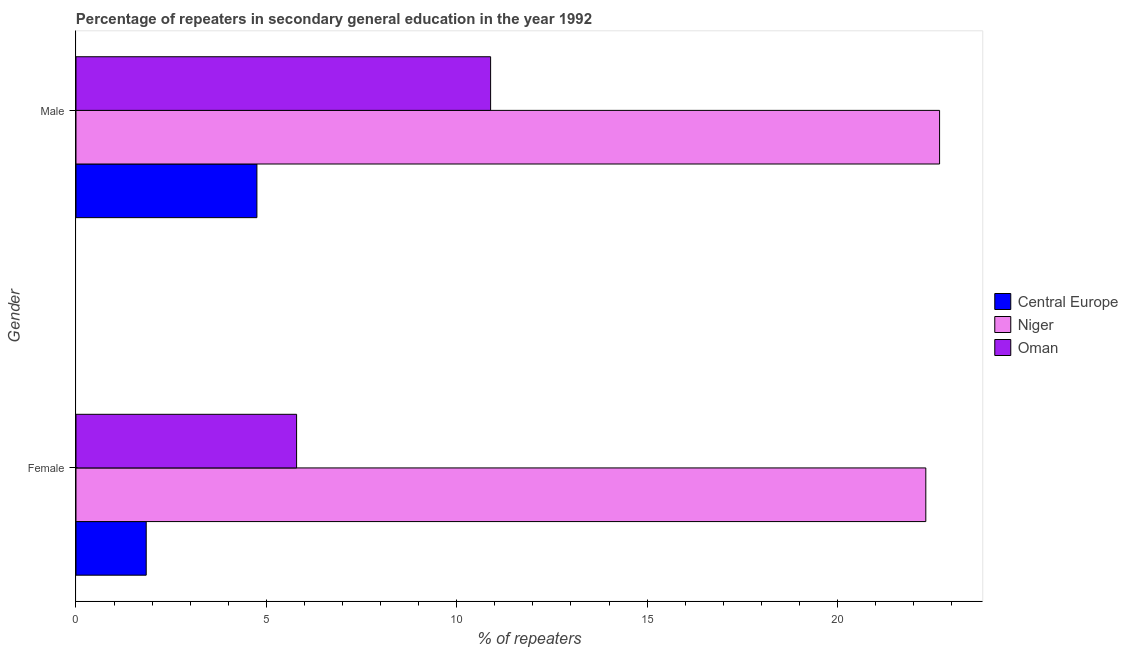How many different coloured bars are there?
Offer a very short reply. 3. How many groups of bars are there?
Your response must be concise. 2. Are the number of bars per tick equal to the number of legend labels?
Keep it short and to the point. Yes. What is the percentage of male repeaters in Central Europe?
Make the answer very short. 4.75. Across all countries, what is the maximum percentage of male repeaters?
Offer a terse response. 22.68. Across all countries, what is the minimum percentage of female repeaters?
Provide a succinct answer. 1.84. In which country was the percentage of female repeaters maximum?
Make the answer very short. Niger. In which country was the percentage of female repeaters minimum?
Provide a succinct answer. Central Europe. What is the total percentage of female repeaters in the graph?
Offer a terse response. 29.96. What is the difference between the percentage of male repeaters in Oman and that in Niger?
Your response must be concise. -11.79. What is the difference between the percentage of male repeaters in Central Europe and the percentage of female repeaters in Niger?
Your answer should be compact. -17.57. What is the average percentage of female repeaters per country?
Provide a succinct answer. 9.99. What is the difference between the percentage of female repeaters and percentage of male repeaters in Oman?
Provide a succinct answer. -5.1. What is the ratio of the percentage of male repeaters in Niger to that in Central Europe?
Provide a short and direct response. 4.77. What does the 2nd bar from the top in Female represents?
Keep it short and to the point. Niger. What does the 1st bar from the bottom in Male represents?
Provide a short and direct response. Central Europe. Are all the bars in the graph horizontal?
Keep it short and to the point. Yes. How many countries are there in the graph?
Offer a very short reply. 3. Are the values on the major ticks of X-axis written in scientific E-notation?
Make the answer very short. No. Does the graph contain any zero values?
Ensure brevity in your answer.  No. How many legend labels are there?
Provide a succinct answer. 3. What is the title of the graph?
Your answer should be compact. Percentage of repeaters in secondary general education in the year 1992. Does "Ireland" appear as one of the legend labels in the graph?
Offer a terse response. No. What is the label or title of the X-axis?
Keep it short and to the point. % of repeaters. What is the % of repeaters in Central Europe in Female?
Provide a short and direct response. 1.84. What is the % of repeaters in Niger in Female?
Offer a terse response. 22.32. What is the % of repeaters in Oman in Female?
Your answer should be very brief. 5.79. What is the % of repeaters in Central Europe in Male?
Give a very brief answer. 4.75. What is the % of repeaters in Niger in Male?
Provide a succinct answer. 22.68. What is the % of repeaters in Oman in Male?
Provide a succinct answer. 10.89. Across all Gender, what is the maximum % of repeaters in Central Europe?
Make the answer very short. 4.75. Across all Gender, what is the maximum % of repeaters in Niger?
Provide a succinct answer. 22.68. Across all Gender, what is the maximum % of repeaters in Oman?
Your answer should be very brief. 10.89. Across all Gender, what is the minimum % of repeaters in Central Europe?
Ensure brevity in your answer.  1.84. Across all Gender, what is the minimum % of repeaters of Niger?
Your response must be concise. 22.32. Across all Gender, what is the minimum % of repeaters of Oman?
Offer a terse response. 5.79. What is the total % of repeaters in Central Europe in the graph?
Your answer should be compact. 6.6. What is the total % of repeaters in Niger in the graph?
Your answer should be compact. 45. What is the total % of repeaters in Oman in the graph?
Keep it short and to the point. 16.68. What is the difference between the % of repeaters in Central Europe in Female and that in Male?
Offer a very short reply. -2.91. What is the difference between the % of repeaters in Niger in Female and that in Male?
Your response must be concise. -0.36. What is the difference between the % of repeaters in Oman in Female and that in Male?
Your response must be concise. -5.1. What is the difference between the % of repeaters of Central Europe in Female and the % of repeaters of Niger in Male?
Offer a very short reply. -20.84. What is the difference between the % of repeaters of Central Europe in Female and the % of repeaters of Oman in Male?
Offer a terse response. -9.05. What is the difference between the % of repeaters of Niger in Female and the % of repeaters of Oman in Male?
Keep it short and to the point. 11.43. What is the average % of repeaters of Central Europe per Gender?
Your answer should be compact. 3.3. What is the average % of repeaters of Niger per Gender?
Give a very brief answer. 22.5. What is the average % of repeaters of Oman per Gender?
Your response must be concise. 8.34. What is the difference between the % of repeaters in Central Europe and % of repeaters in Niger in Female?
Offer a terse response. -20.48. What is the difference between the % of repeaters in Central Europe and % of repeaters in Oman in Female?
Ensure brevity in your answer.  -3.95. What is the difference between the % of repeaters of Niger and % of repeaters of Oman in Female?
Your response must be concise. 16.53. What is the difference between the % of repeaters of Central Europe and % of repeaters of Niger in Male?
Ensure brevity in your answer.  -17.93. What is the difference between the % of repeaters in Central Europe and % of repeaters in Oman in Male?
Make the answer very short. -6.14. What is the difference between the % of repeaters of Niger and % of repeaters of Oman in Male?
Your response must be concise. 11.79. What is the ratio of the % of repeaters of Central Europe in Female to that in Male?
Offer a terse response. 0.39. What is the ratio of the % of repeaters of Niger in Female to that in Male?
Offer a terse response. 0.98. What is the ratio of the % of repeaters in Oman in Female to that in Male?
Offer a terse response. 0.53. What is the difference between the highest and the second highest % of repeaters in Central Europe?
Your answer should be compact. 2.91. What is the difference between the highest and the second highest % of repeaters of Niger?
Your answer should be very brief. 0.36. What is the difference between the highest and the second highest % of repeaters of Oman?
Ensure brevity in your answer.  5.1. What is the difference between the highest and the lowest % of repeaters of Central Europe?
Your answer should be very brief. 2.91. What is the difference between the highest and the lowest % of repeaters in Niger?
Offer a terse response. 0.36. What is the difference between the highest and the lowest % of repeaters in Oman?
Make the answer very short. 5.1. 